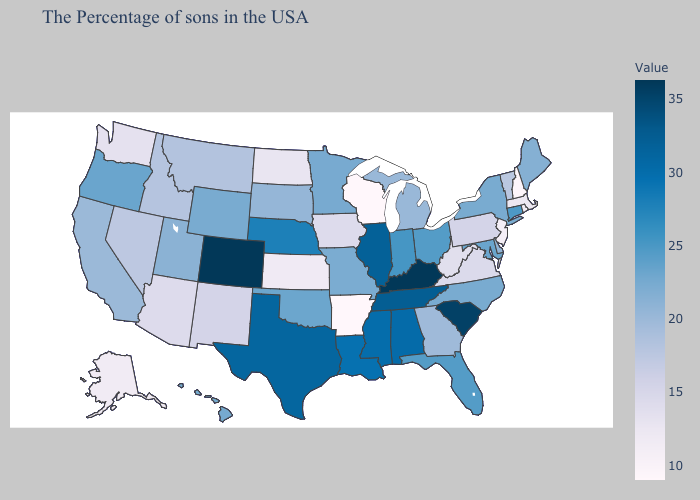Does Washington have the lowest value in the USA?
Short answer required. No. Does Alaska have the lowest value in the West?
Give a very brief answer. Yes. Which states hav the highest value in the South?
Quick response, please. Kentucky. Is the legend a continuous bar?
Write a very short answer. Yes. Does Texas have a higher value than South Carolina?
Write a very short answer. No. Does Connecticut have a lower value than Nebraska?
Answer briefly. Yes. Among the states that border Idaho , which have the lowest value?
Be succinct. Washington. 